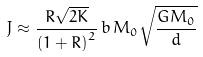Convert formula to latex. <formula><loc_0><loc_0><loc_500><loc_500>J \approx \frac { R \sqrt { 2 K } } { { ( 1 + R ) } ^ { 2 } } \, b \, M _ { 0 } \sqrt { \frac { G M _ { 0 } } { d } }</formula> 